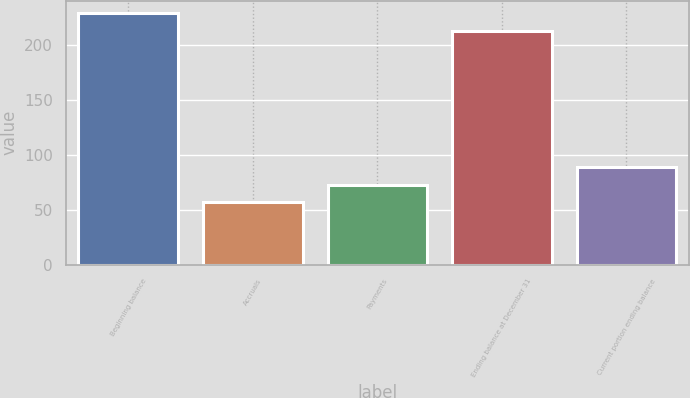<chart> <loc_0><loc_0><loc_500><loc_500><bar_chart><fcel>Beginning balance<fcel>Accruals<fcel>Payments<fcel>Ending balance at December 31<fcel>Current portion ending balance<nl><fcel>229<fcel>57<fcel>73<fcel>213<fcel>89<nl></chart> 